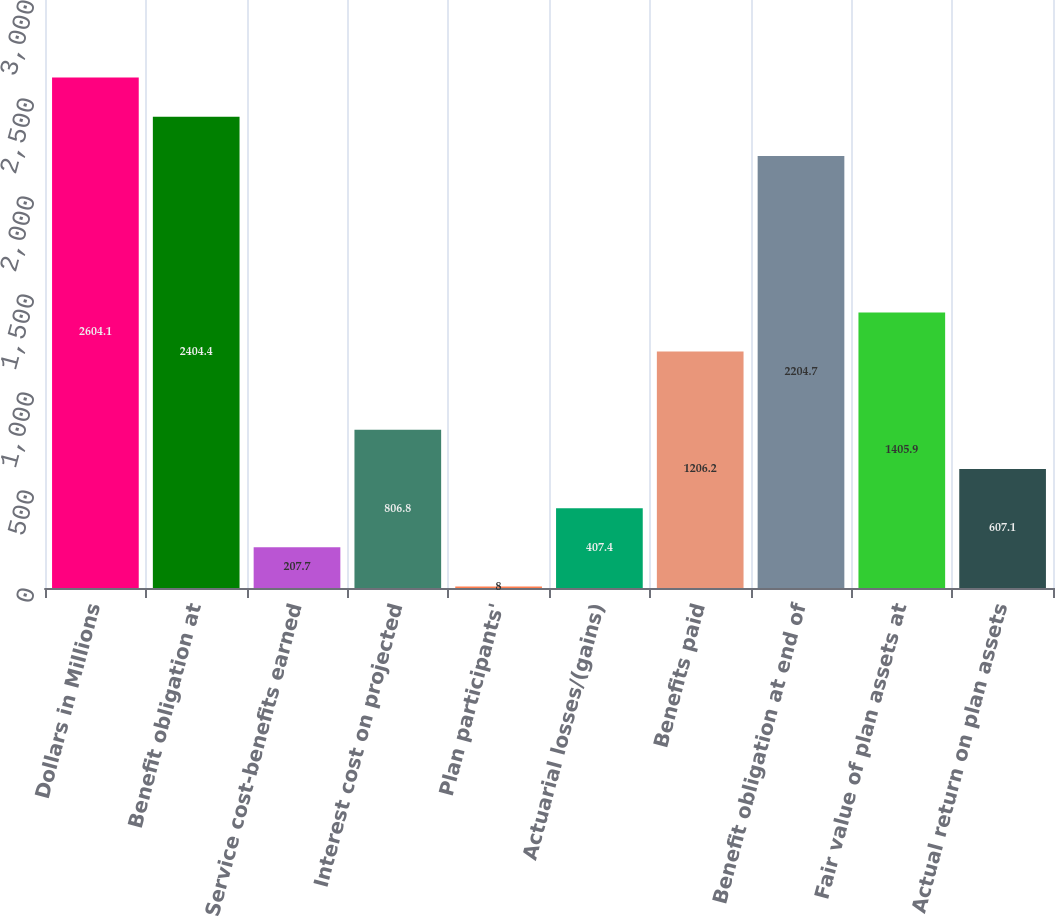Convert chart to OTSL. <chart><loc_0><loc_0><loc_500><loc_500><bar_chart><fcel>Dollars in Millions<fcel>Benefit obligation at<fcel>Service cost-benefits earned<fcel>Interest cost on projected<fcel>Plan participants'<fcel>Actuarial losses/(gains)<fcel>Benefits paid<fcel>Benefit obligation at end of<fcel>Fair value of plan assets at<fcel>Actual return on plan assets<nl><fcel>2604.1<fcel>2404.4<fcel>207.7<fcel>806.8<fcel>8<fcel>407.4<fcel>1206.2<fcel>2204.7<fcel>1405.9<fcel>607.1<nl></chart> 